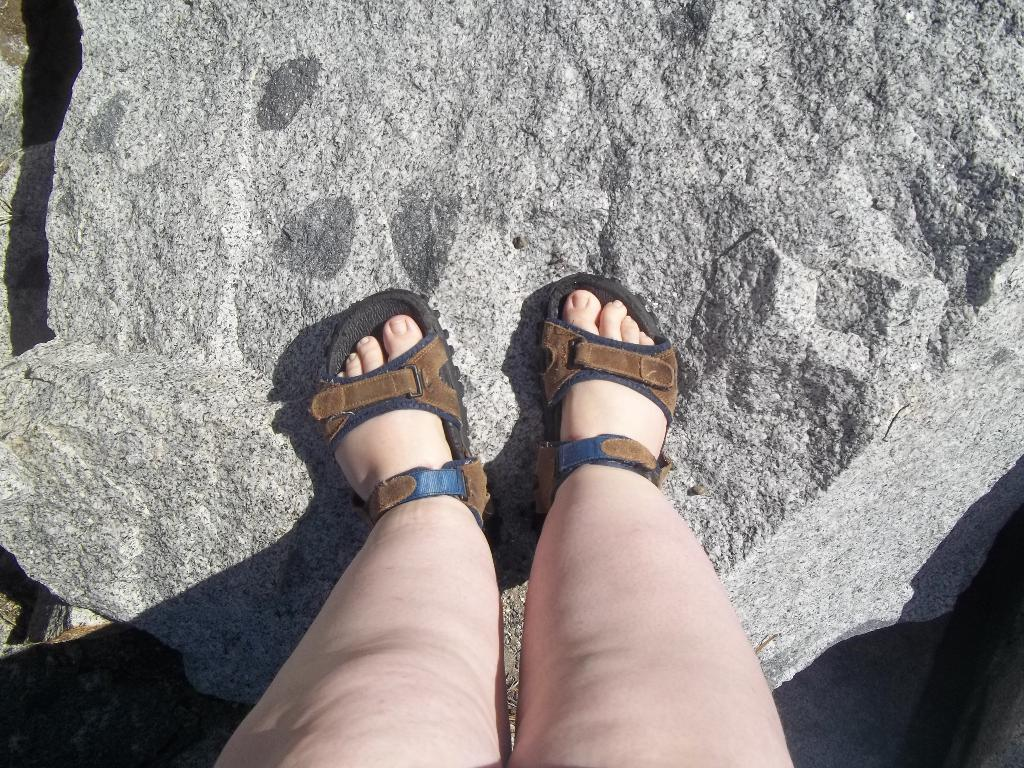What body parts are visible in the image? There are two human legs in the image. What type of footwear is associated with the legs in the image? There are two sandals in the image. What natural object can be seen in the image? There is a rock in the image. What type of club is being used to celebrate the birthday in the image? There is no club or birthday celebration present in the image. 